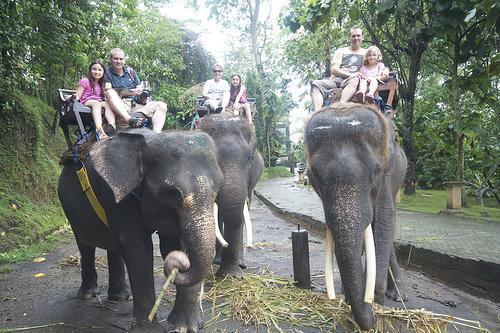How many elephants are the people riding?
Give a very brief answer. 3. 